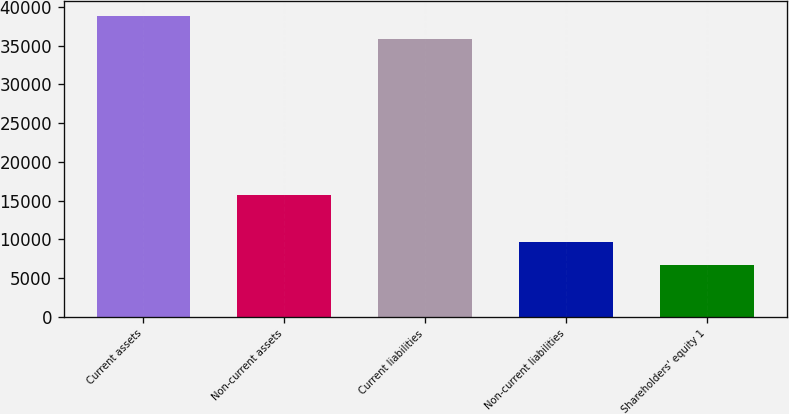<chart> <loc_0><loc_0><loc_500><loc_500><bar_chart><fcel>Current assets<fcel>Non-current assets<fcel>Current liabilities<fcel>Non-current liabilities<fcel>Shareholders' equity 1<nl><fcel>38835<fcel>15710<fcel>35857<fcel>9721<fcel>6743<nl></chart> 